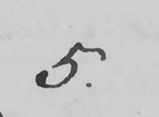What text is written in this handwritten line? 5 . 